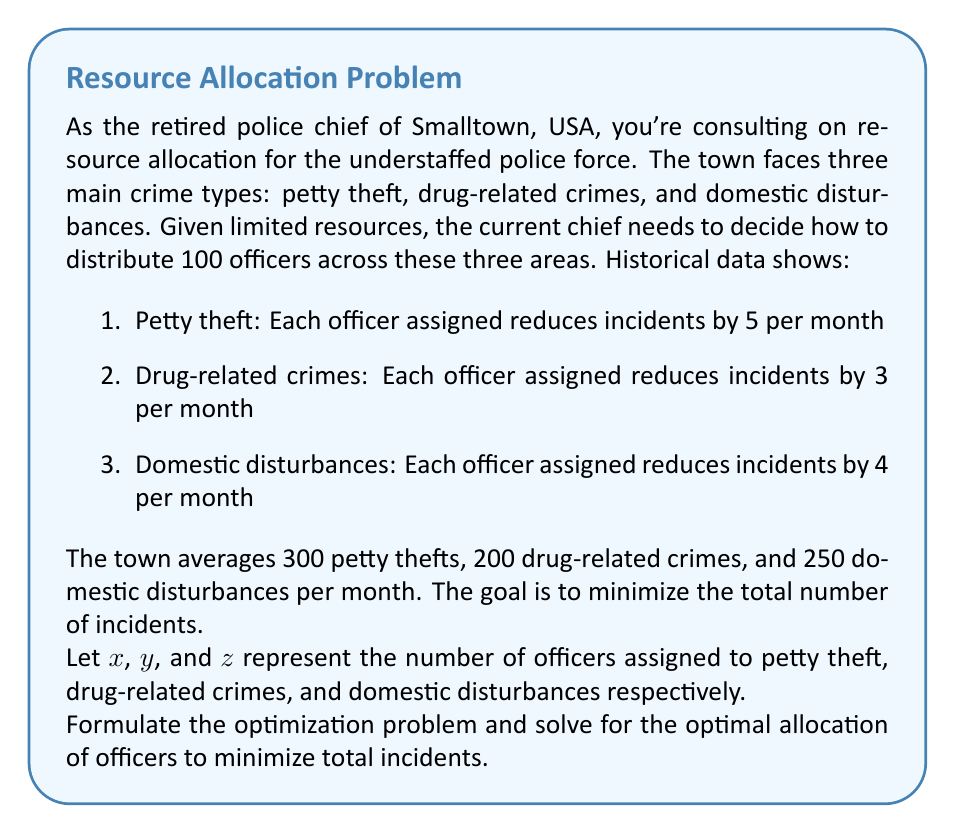Help me with this question. To solve this problem, we'll use linear programming. Let's follow these steps:

1) Formulate the objective function:
   We want to minimize the total number of incidents after officer allocation.
   
   $\text{Total incidents} = (300 - 5x) + (200 - 3y) + (250 - 4z)$
   
   Simplifying: $750 - 5x - 3y - 4z$

2) Define the constraints:
   a) Total number of officers: $x + y + z = 100$
   b) Non-negativity: $x \geq 0, y \geq 0, z \geq 0$

3) The linear programming problem becomes:

   Minimize: $750 - 5x - 3y - 4z$
   Subject to:
   $x + y + z = 100$
   $x, y, z \geq 0$

4) To solve this, we can use the simplex method or other linear programming techniques. However, given the simple nature of this problem, we can also use a more intuitive approach.

5) Notice that the objective function is minimized when we allocate more officers to areas with higher impact (coefficient in the objective function).

6) Ranking the impact:
   Petty theft: 5 incidents/officer
   Domestic disturbances: 4 incidents/officer
   Drug-related crimes: 3 incidents/officer

7) Optimal allocation strategy:
   - Assign officers to petty theft until it's reduced to zero or we run out of officers
   - If officers remain, assign to domestic disturbances
   - If officers still remain, assign to drug-related crimes

8) Calculations:
   - Petty theft needs 300/5 = 60 officers to reduce to zero
   - Assign 60 officers to petty theft
   - 40 officers remain
   - Domestic disturbances need 250/4 = 62.5 officers to reduce to zero
   - Assign remaining 40 officers to domestic disturbances

9) Final allocation:
   $x = 60$ (petty theft)
   $z = 40$ (domestic disturbances)
   $y = 0$ (drug-related crimes)

10) Verifying the constraint: $60 + 40 + 0 = 100$

11) Calculating final incidents:
    Petty theft: $300 - (5 * 60) = 0$
    Domestic disturbances: $250 - (4 * 40) = 90$
    Drug-related crimes: $200 - (3 * 0) = 200$
    
    Total incidents: $0 + 90 + 200 = 290$
Answer: The optimal allocation is 60 officers to petty theft, 40 officers to domestic disturbances, and 0 officers to drug-related crimes. This results in a minimum of 290 total incidents per month. 